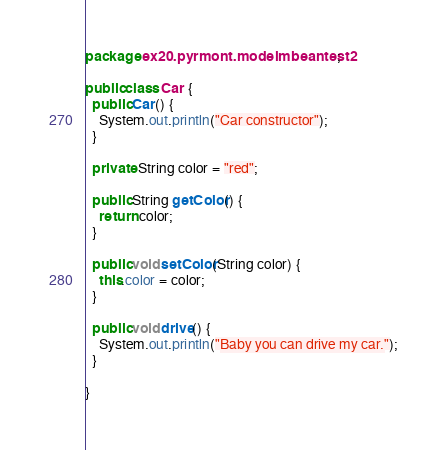<code> <loc_0><loc_0><loc_500><loc_500><_Java_>package ex20.pyrmont.modelmbeantest2;

public class Car {
  public Car() {
    System.out.println("Car constructor");
  }

  private String color = "red";

  public String getColor() {
    return color;
  }

  public void setColor(String color) {
    this.color = color;
  }

  public void drive() {
    System.out.println("Baby you can drive my car.");
  }

}
</code> 